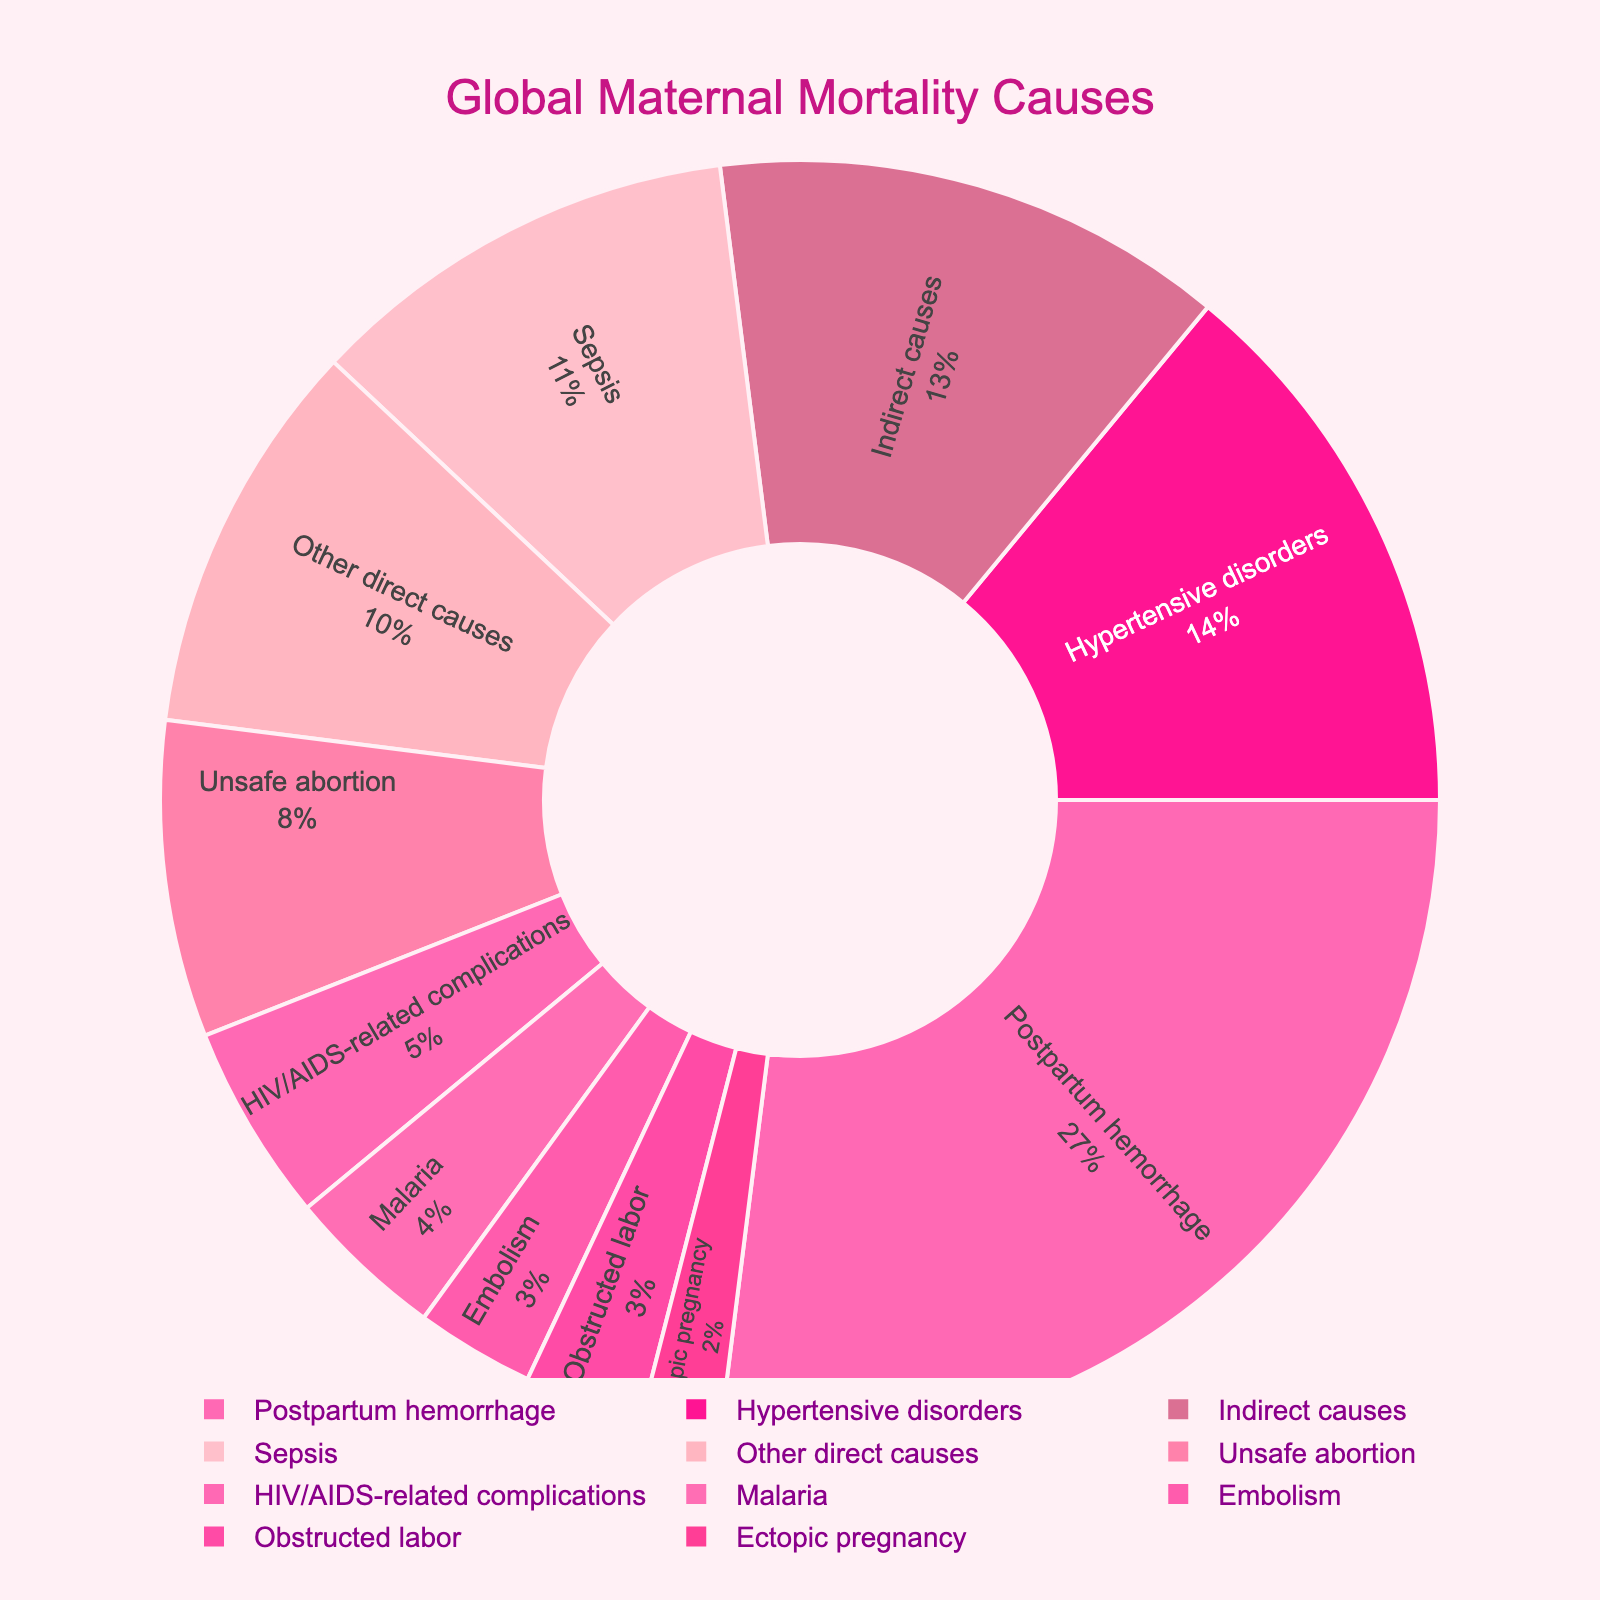What percentage of global maternal mortality is caused by hypertensive disorders? The pie chart shows the percentage of each cause of global maternal mortality. Find "Hypertensive disorders" in the chart's legend and read the corresponding percentage.
Answer: 14% What is the combined percentage of maternal mortality due to postpartum hemorrhage and sepsis? Identify the percentages for "Postpartum hemorrhage" and "Sepsis" from the pie chart. Add these two percentages together: 27% + 11% = 38%.
Answer: 38% Which cause has a lower percentage, obstructed labor or ectopic pregnancy? Locate the percentages for "Obstructed labor" and "Ectopic pregnancy" in the chart and compare them. "Obstructed labor" is 3%, and "Ectopic pregnancy" is 2%.
Answer: Ectopic pregnancy How does the percentage of maternal mortality caused by unsafe abortion compare to that by HIV/AIDS-related complications? Compare the percentages given in the chart for "Unsafe abortion" (8%) and "HIV/AIDS-related complications" (5%). Unsafe abortion has a higher percentage.
Answer: Unsafe abortion is higher Which maternal mortality cause has the largest percentage? Review the chart to find the cause with the highest percentage. Postpartum hemorrhage shows the largest percentage at 27%.
Answer: Postpartum hemorrhage How much greater is the percentage of postpartum hemorrhage than that of indirect causes? Identify the percentages for "Postpartum hemorrhage" and "Indirect causes" from the chart. Subtract the percentage of indirect causes from that of postpartum hemorrhage: 27% - 13% = 14%.
Answer: 14% Sum the contributions of embolism, ectopic pregnancy, and malaria to global maternal mortality. Locate the percentages for "Embolism" (3%), "Ectopic pregnancy" (2%), and "Malaria" (4%). Add these percentages together: 3% + 2% + 4% = 9%.
Answer: 9% What direct causes of maternal mortality have a percentage greater than 10%? Identify the direct causes listed in the chart and check which ones have a percentage greater than 10%. These causes are "Postpartum hemorrhage" (27%), "Hypertensive disorders" (14%), and "Sepsis" (11%).
Answer: Postpartum hemorrhage, Hypertensive disorders, and Sepsis What is the visual difference between the slices representing "Unsafe abortion" and "Other direct causes"? Evaluate the colors and positioning of the pie chart segments for "Unsafe abortion" and "Other direct causes". "Unsafe abortion" is shown in a lighter pink while "Other direct causes" is in a darker pink shade.
Answer: Lighter pink vs darker pink If indirect causes were reduced by 3%, how would the ranking of causes change in terms of percentage? If "Indirect causes" were reduced by 3%, its percentage would be 10% (13% - 3%). Compare this new percentage with other causes. It would now be ranked below "Other direct causes", which remains at 10%. Indirect causes would fall to fifth place, just below "Other direct causes".
Answer: Fifth place, below "Other direct causes" 